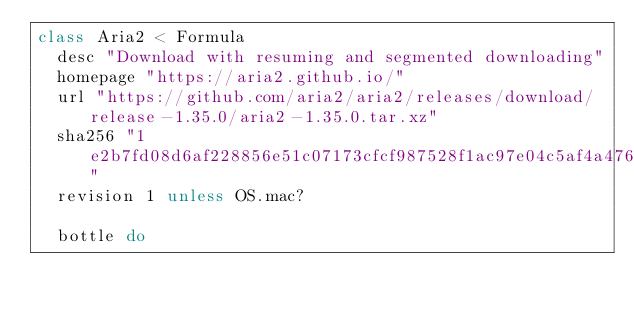<code> <loc_0><loc_0><loc_500><loc_500><_Ruby_>class Aria2 < Formula
  desc "Download with resuming and segmented downloading"
  homepage "https://aria2.github.io/"
  url "https://github.com/aria2/aria2/releases/download/release-1.35.0/aria2-1.35.0.tar.xz"
  sha256 "1e2b7fd08d6af228856e51c07173cfcf987528f1ac97e04c5af4a47642617dfd"
  revision 1 unless OS.mac?

  bottle do</code> 